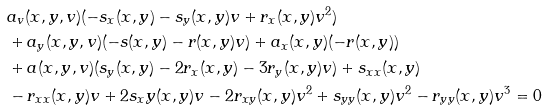<formula> <loc_0><loc_0><loc_500><loc_500>& a _ { v } ( x , y , v ) ( - s _ { x } ( x , y ) - s _ { y } ( x , y ) v + r _ { x } ( x , y ) v ^ { 2 } ) \\ & + a _ { y } ( x , y , v ) ( - s ( x , y ) - r ( x , y ) v ) + a _ { x } ( x , y ) ( - r ( x , y ) ) \\ & + a ( x , y , v ) ( s _ { y } ( x , y ) - 2 r _ { x } ( x , y ) - 3 r _ { y } ( x , y ) v ) + s _ { x x } ( x , y ) \\ & - r _ { x x } ( x , y ) v + 2 s _ { x } y ( x , y ) v - 2 r _ { x y } ( x , y ) v ^ { 2 } + s _ { y y } ( x , y ) v ^ { 2 } - r _ { y y } ( x , y ) v ^ { 3 } = 0</formula> 